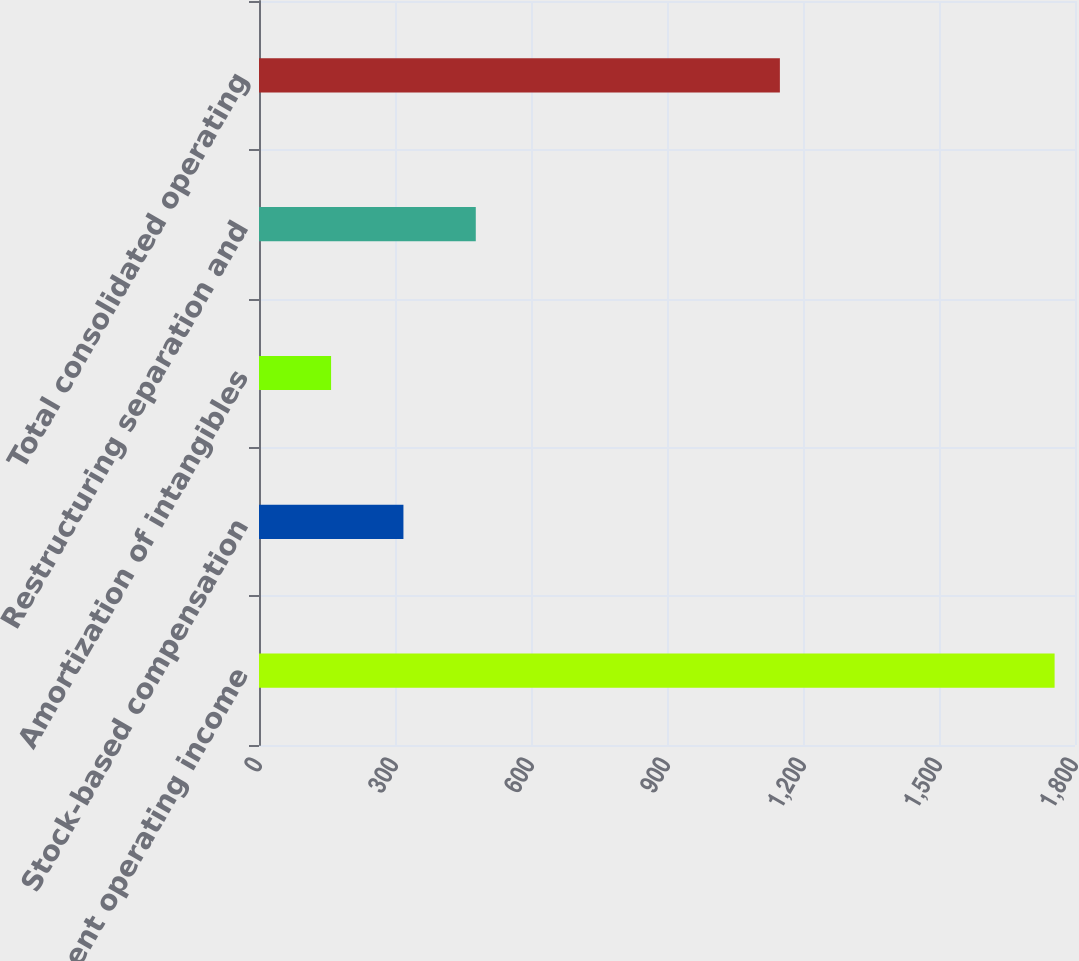<chart> <loc_0><loc_0><loc_500><loc_500><bar_chart><fcel>Total segment operating income<fcel>Stock-based compensation<fcel>Amortization of intangibles<fcel>Restructuring separation and<fcel>Total consolidated operating<nl><fcel>1755<fcel>318.6<fcel>159<fcel>478.2<fcel>1149<nl></chart> 